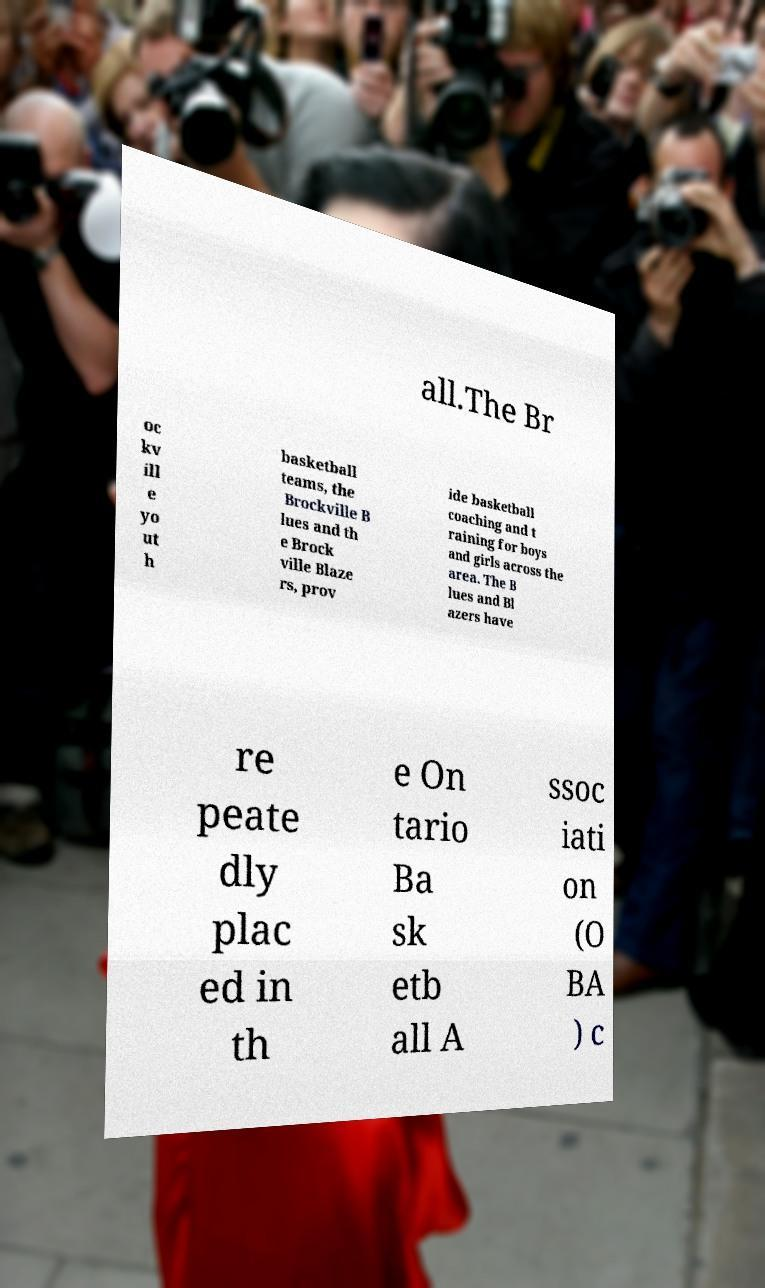Can you read and provide the text displayed in the image?This photo seems to have some interesting text. Can you extract and type it out for me? all.The Br oc kv ill e yo ut h basketball teams, the Brockville B lues and th e Brock ville Blaze rs, prov ide basketball coaching and t raining for boys and girls across the area. The B lues and Bl azers have re peate dly plac ed in th e On tario Ba sk etb all A ssoc iati on (O BA ) c 